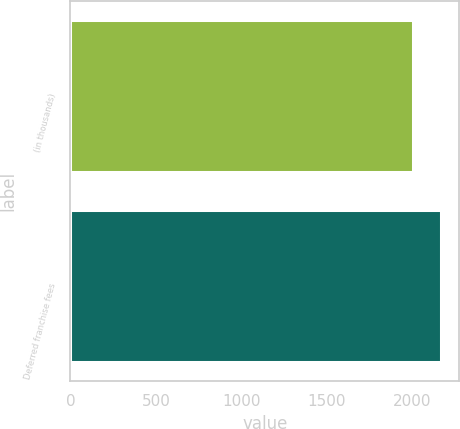Convert chart to OTSL. <chart><loc_0><loc_0><loc_500><loc_500><bar_chart><fcel>(in thousands)<fcel>Deferred franchise fees<nl><fcel>2006<fcel>2165<nl></chart> 